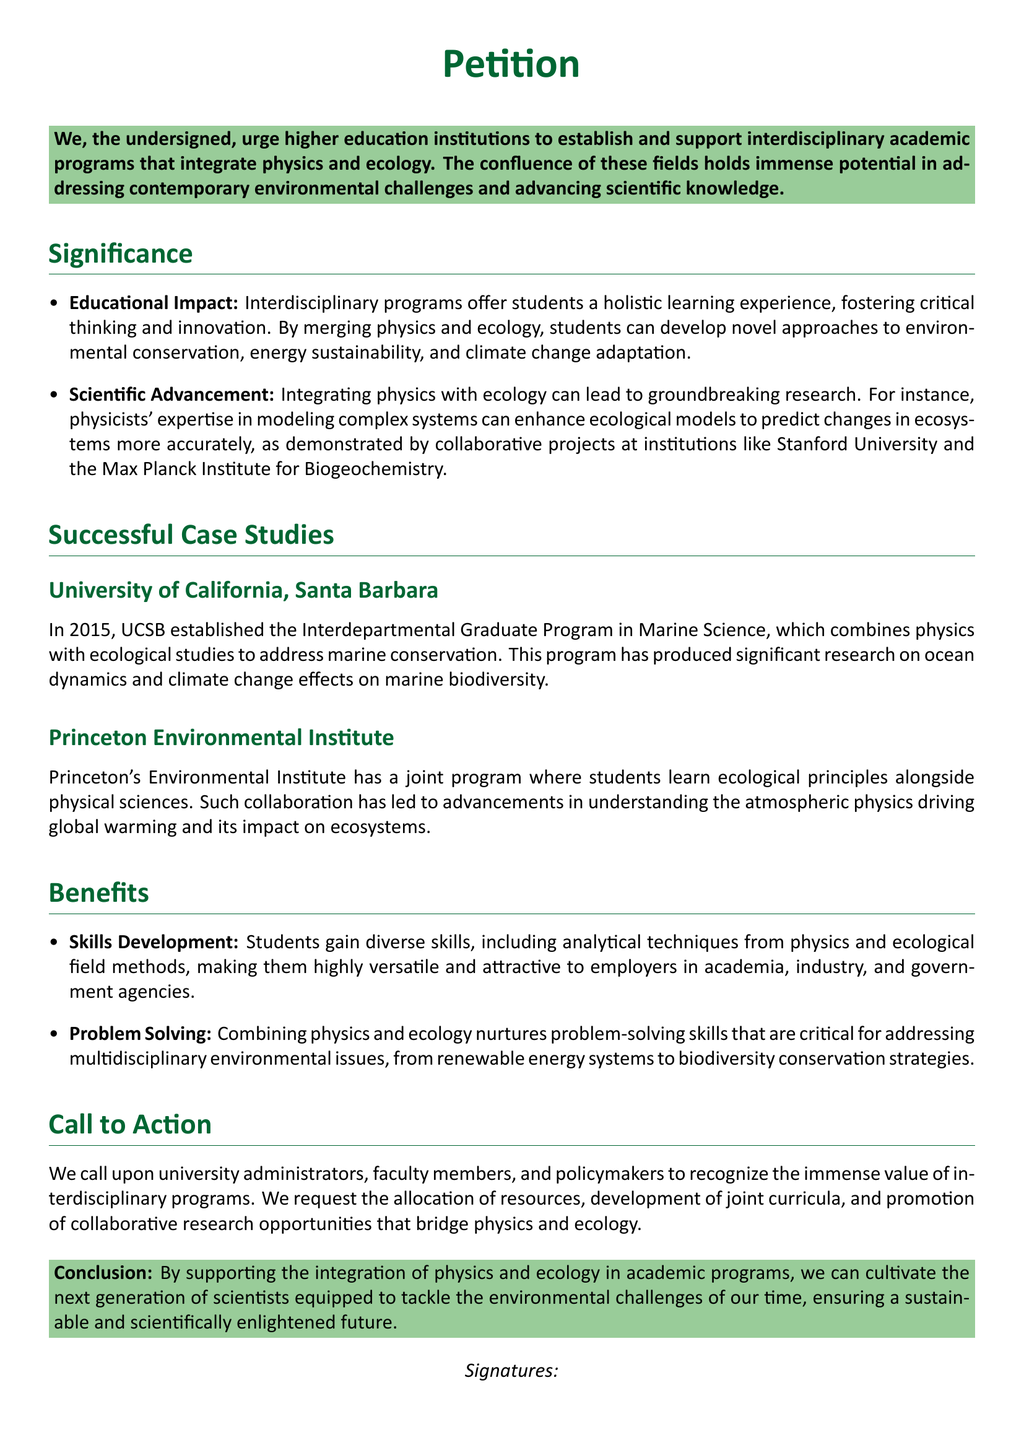What is the main objective of the petition? The primary aim outlined in the petition is to support the establishment of interdisciplinary programs that combine physics and ecology.
Answer: To support interdisciplinary academic programs combining physics and ecology What year was the Interdepartmental Graduate Program in Marine Science established at UCSB? The document states that the UCSB program was established in 2015.
Answer: 2015 Which university is mentioned for its Environmental Institute's joint program? The document specifically names Princeton University for its Environmental Institute's joint program.
Answer: Princeton University What are two areas mentioned where physics and ecology integration can lead to advancements? The document lists ocean dynamics and understanding atmospheric physics as two key areas of advancement.
Answer: Ocean dynamics and atmospheric physics What type of skills do students develop through the programs? The petition mentions that students gain diverse skills, including analytical techniques from physics and ecological field methods.
Answer: Diverse skills, analytical techniques, and ecological field methods What is a key call to action in the petition? The petition calls for the allocation of resources and development of joint curricula for interdisciplinary programs.
Answer: Allocation of resources and development of joint curricula What does the petition emphasize about the learning experience provided by interdisciplinary programs? The document states that such programs offer a holistic learning experience.
Answer: Holistic learning experience How does the petition describe the potential of interdisciplinary programs? The potential of interdisciplinary programs is indicated to hold immense promise in addressing contemporary environmental challenges.
Answer: Immense promise in addressing environmental challenges 